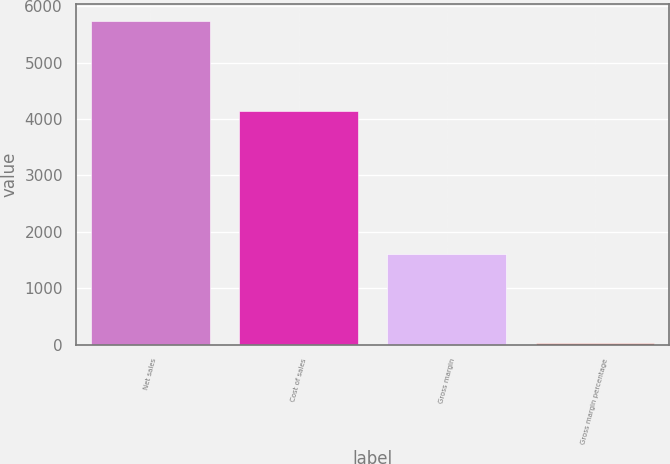<chart> <loc_0><loc_0><loc_500><loc_500><bar_chart><fcel>Net sales<fcel>Cost of sales<fcel>Gross margin<fcel>Gross margin percentage<nl><fcel>5742<fcel>4139<fcel>1603<fcel>27.9<nl></chart> 